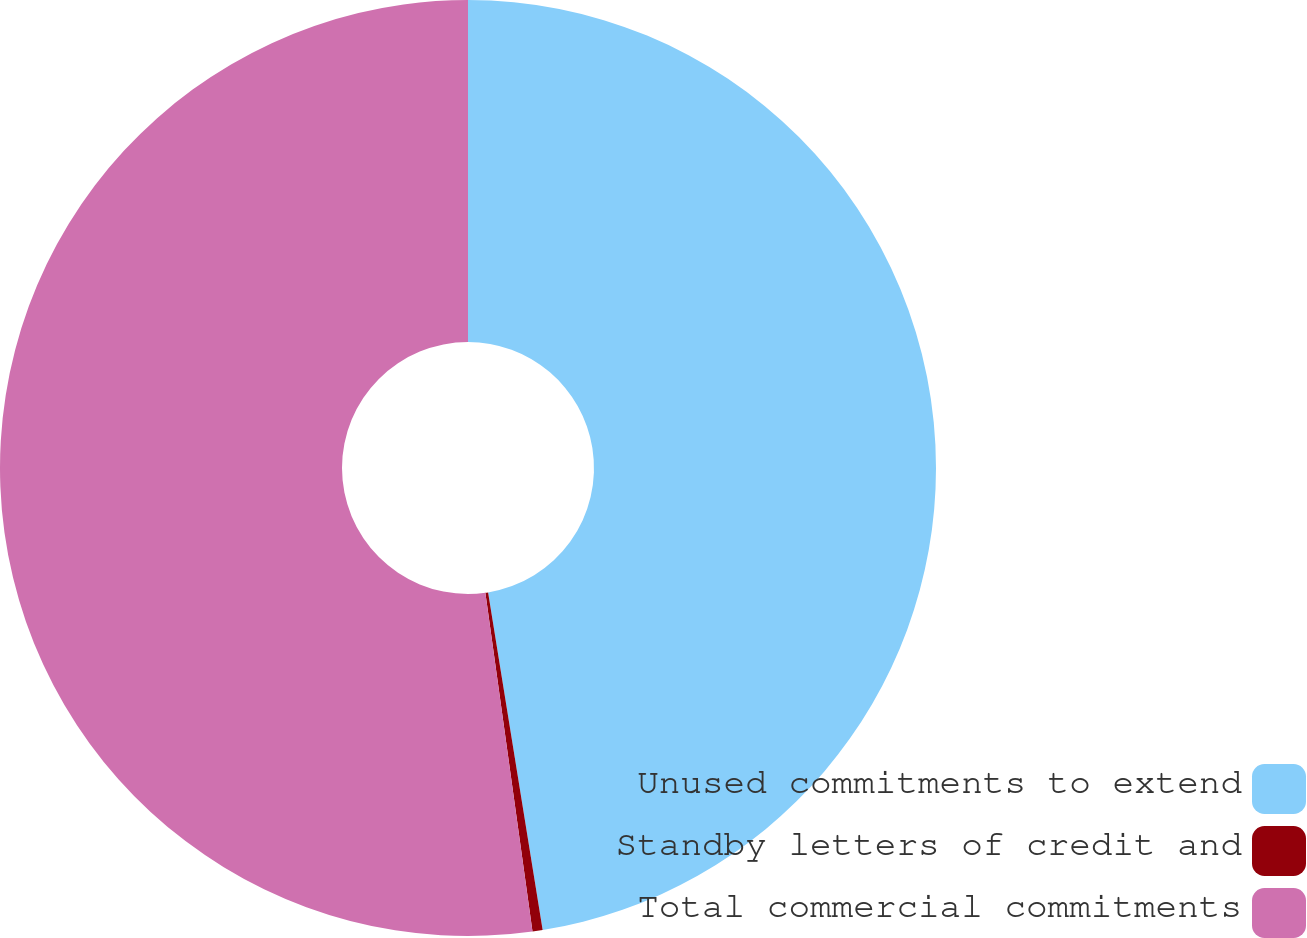<chart> <loc_0><loc_0><loc_500><loc_500><pie_chart><fcel>Unused commitments to extend<fcel>Standby letters of credit and<fcel>Total commercial commitments<nl><fcel>47.45%<fcel>0.35%<fcel>52.2%<nl></chart> 